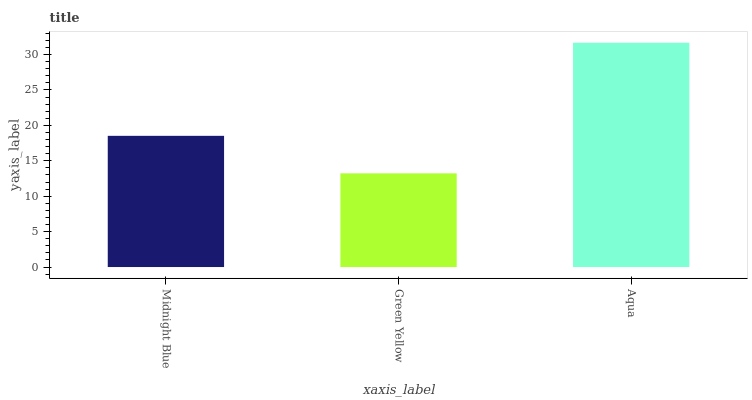Is Green Yellow the minimum?
Answer yes or no. Yes. Is Aqua the maximum?
Answer yes or no. Yes. Is Aqua the minimum?
Answer yes or no. No. Is Green Yellow the maximum?
Answer yes or no. No. Is Aqua greater than Green Yellow?
Answer yes or no. Yes. Is Green Yellow less than Aqua?
Answer yes or no. Yes. Is Green Yellow greater than Aqua?
Answer yes or no. No. Is Aqua less than Green Yellow?
Answer yes or no. No. Is Midnight Blue the high median?
Answer yes or no. Yes. Is Midnight Blue the low median?
Answer yes or no. Yes. Is Green Yellow the high median?
Answer yes or no. No. Is Green Yellow the low median?
Answer yes or no. No. 